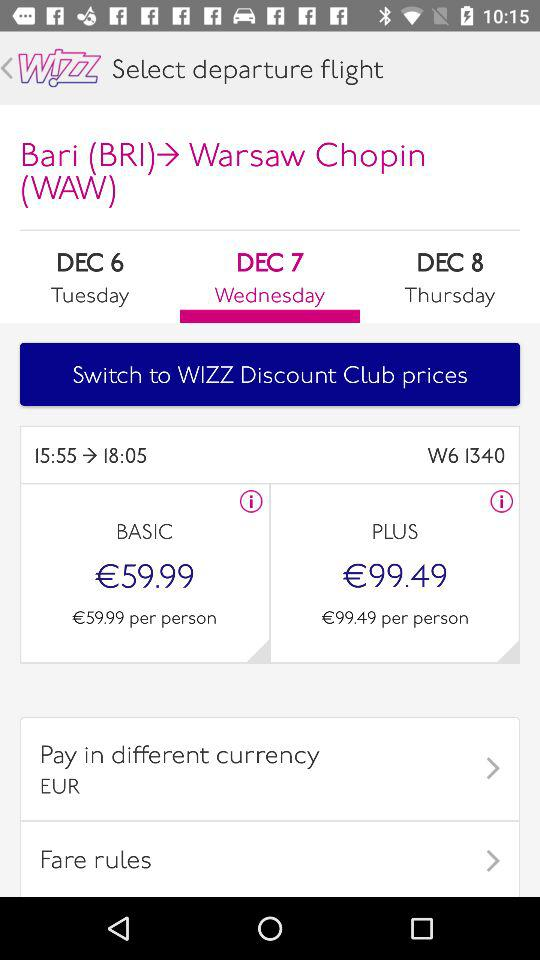How many days are there between the earliest and latest departure dates?
Answer the question using a single word or phrase. 2 